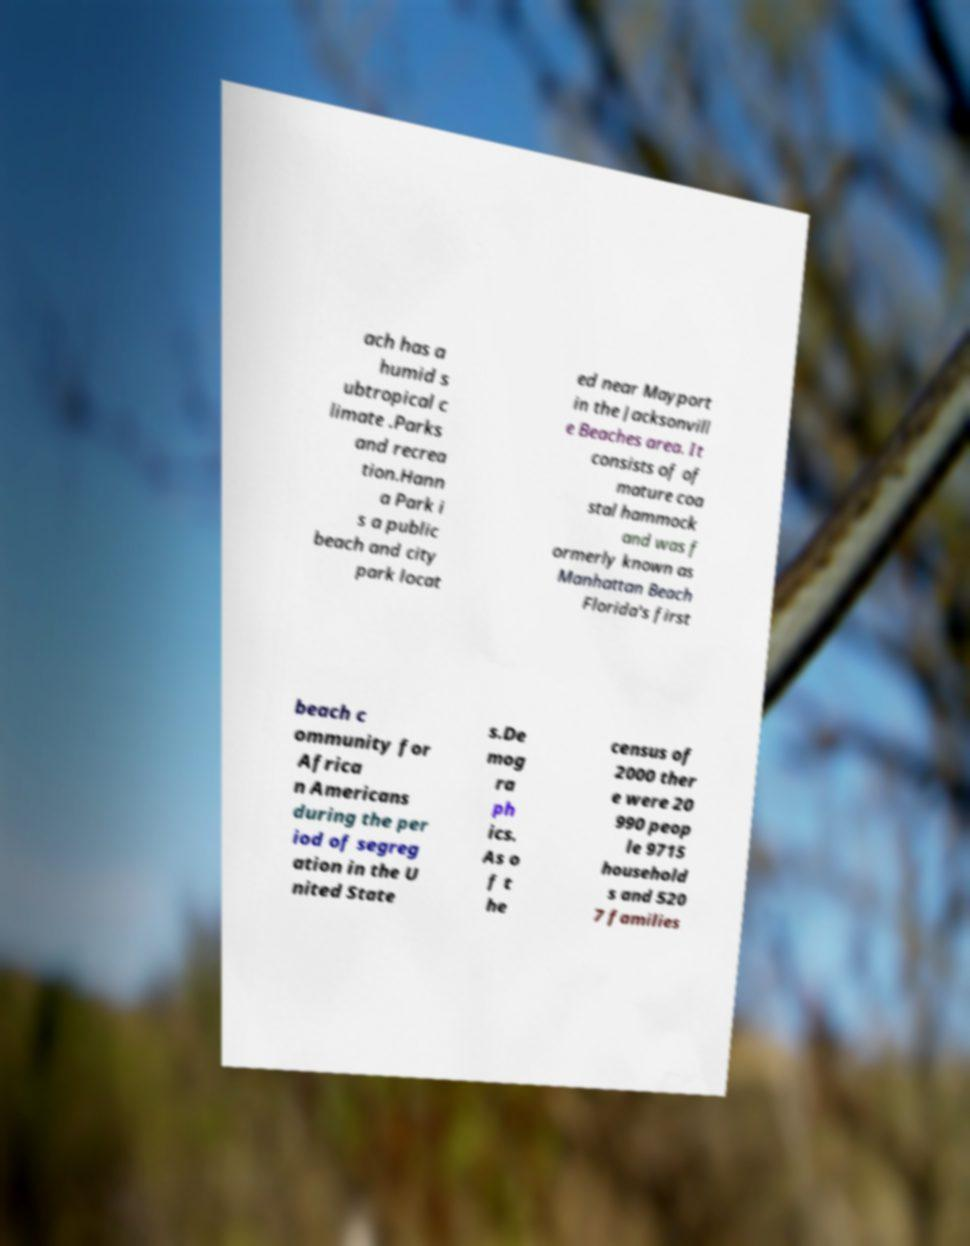For documentation purposes, I need the text within this image transcribed. Could you provide that? ach has a humid s ubtropical c limate .Parks and recrea tion.Hann a Park i s a public beach and city park locat ed near Mayport in the Jacksonvill e Beaches area. It consists of of mature coa stal hammock and was f ormerly known as Manhattan Beach Florida's first beach c ommunity for Africa n Americans during the per iod of segreg ation in the U nited State s.De mog ra ph ics. As o f t he census of 2000 ther e were 20 990 peop le 9715 household s and 520 7 families 